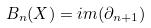Convert formula to latex. <formula><loc_0><loc_0><loc_500><loc_500>B _ { n } ( X ) = i m ( \partial _ { n + 1 } )</formula> 